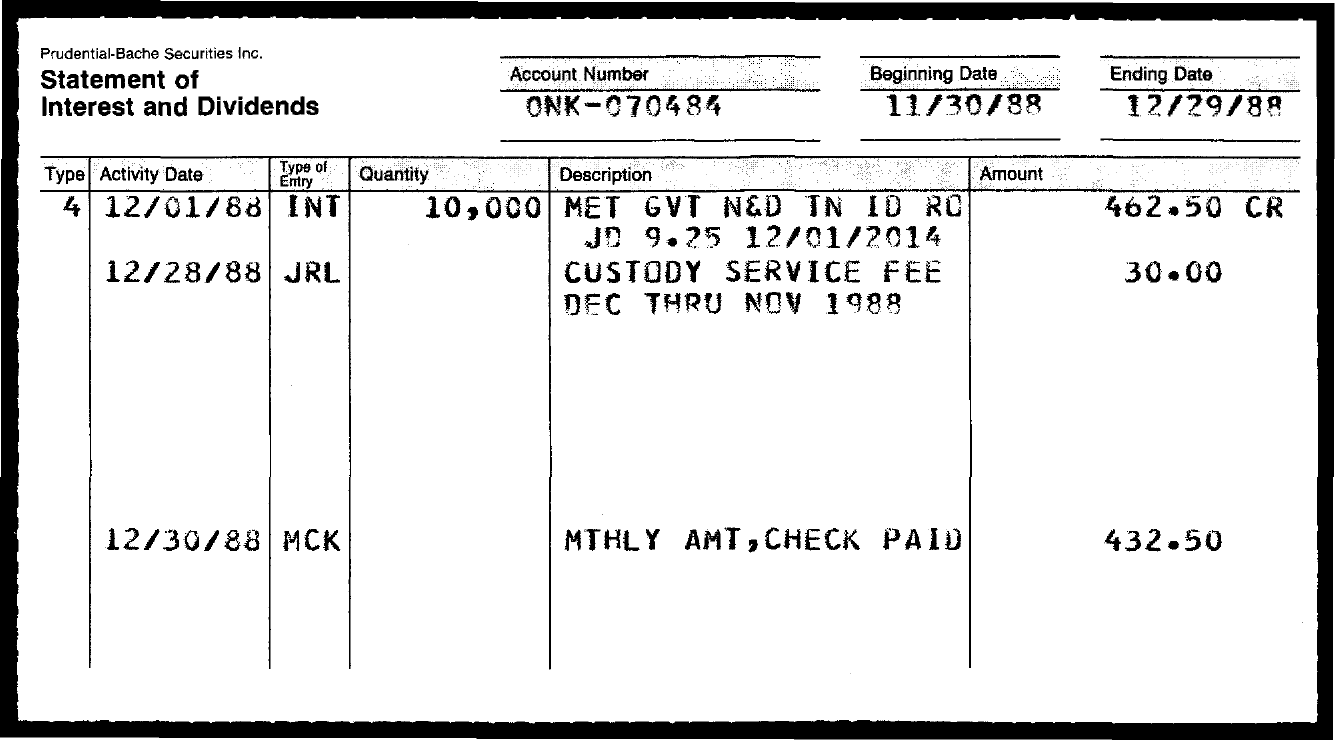Outline some significant characteristics in this image. The entity MCK has a value of 432.50. The account number is ONK-070484. 